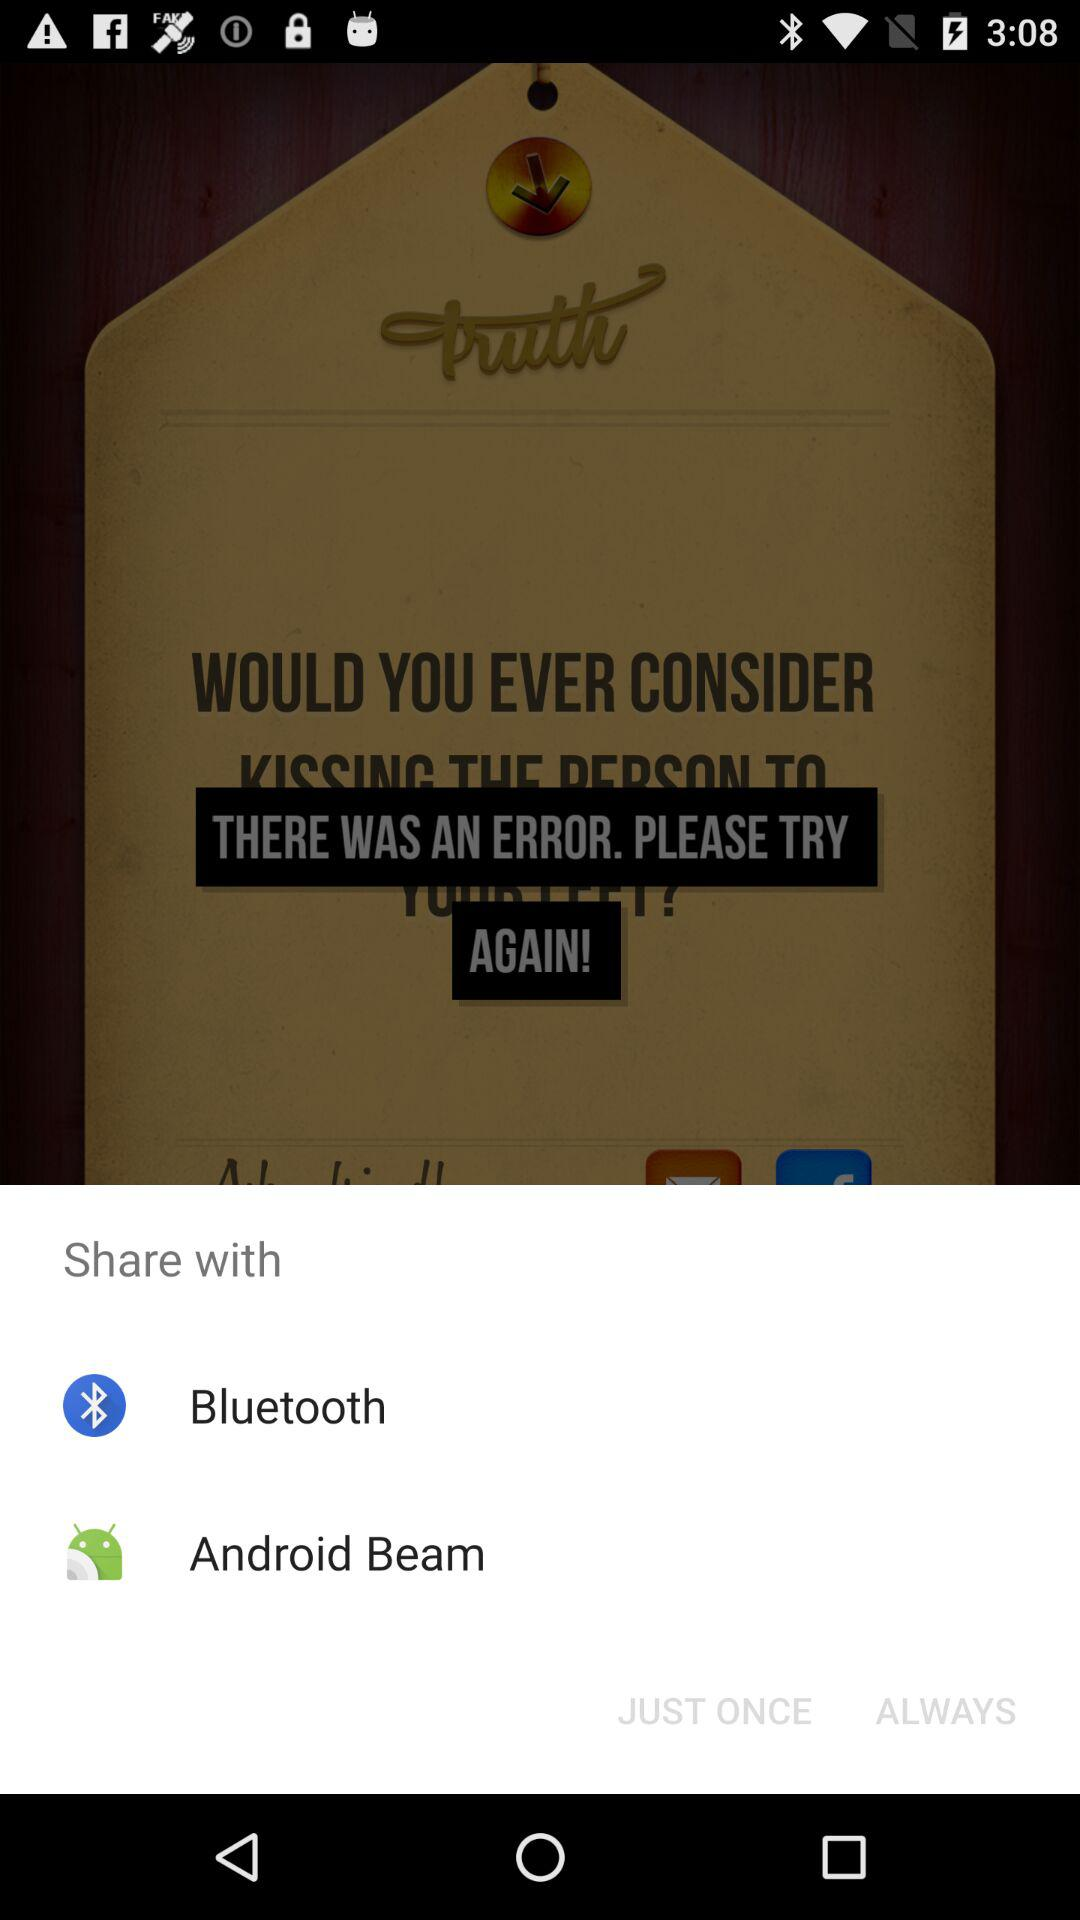Which application can we share it with? You can share it with "Bluetooth" and "Android Beam". 